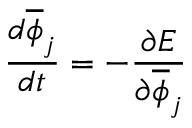<formula> <loc_0><loc_0><loc_500><loc_500>\frac { d \overline { \phi } _ { j } } { d t } = - \frac { \partial E } { \partial \overline { \phi } _ { j } }</formula> 